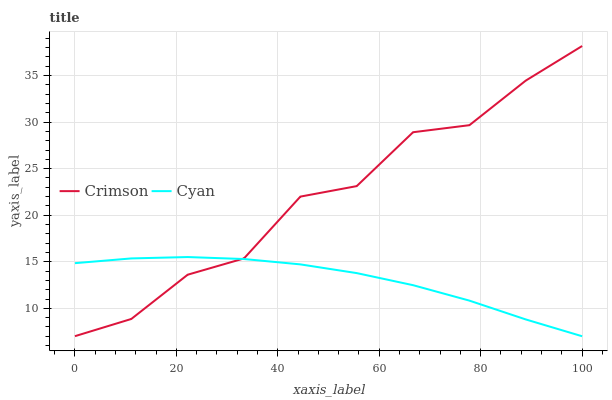Does Cyan have the minimum area under the curve?
Answer yes or no. Yes. Does Crimson have the maximum area under the curve?
Answer yes or no. Yes. Does Cyan have the maximum area under the curve?
Answer yes or no. No. Is Cyan the smoothest?
Answer yes or no. Yes. Is Crimson the roughest?
Answer yes or no. Yes. Is Cyan the roughest?
Answer yes or no. No. Does Cyan have the highest value?
Answer yes or no. No. 